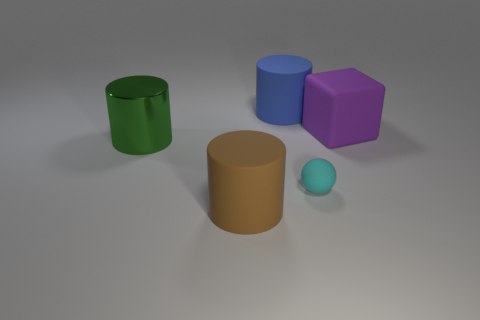Add 1 green metal cylinders. How many objects exist? 6 Subtract all cylinders. How many objects are left? 2 Subtract all yellow matte cylinders. Subtract all big blue matte objects. How many objects are left? 4 Add 5 cylinders. How many cylinders are left? 8 Add 4 big green metallic objects. How many big green metallic objects exist? 5 Subtract 1 green cylinders. How many objects are left? 4 